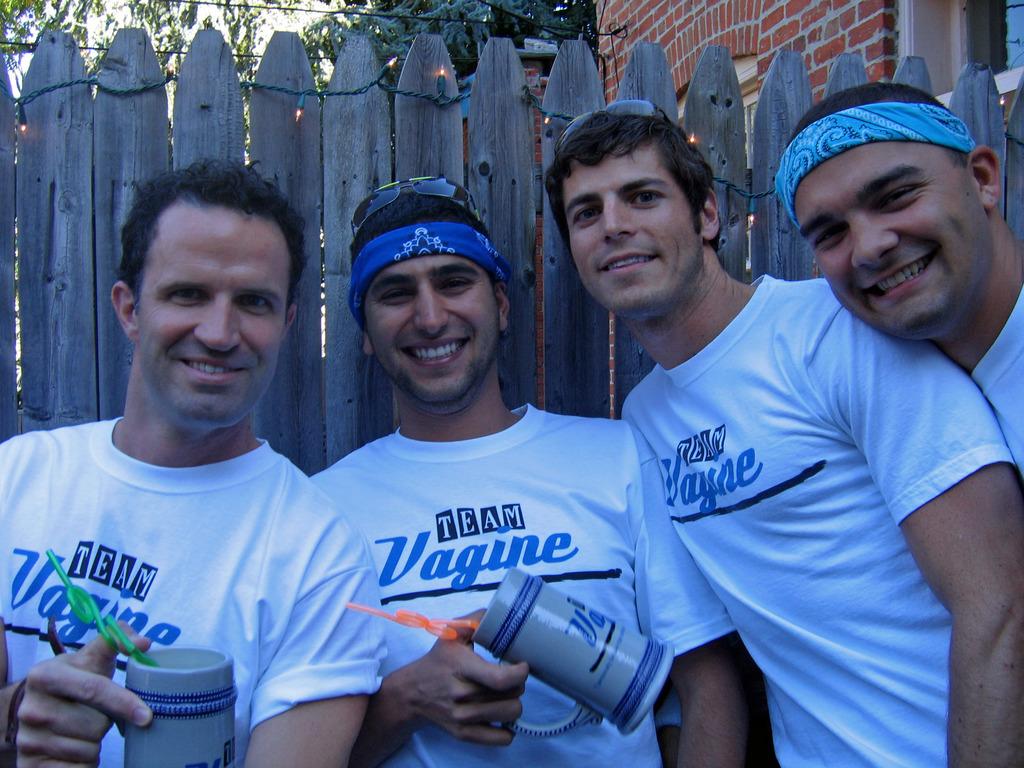What is the team these men are wearing on their shirts?
Make the answer very short. Team vagine. What is the first letter visible on the grey mug?
Your answer should be very brief. V. 